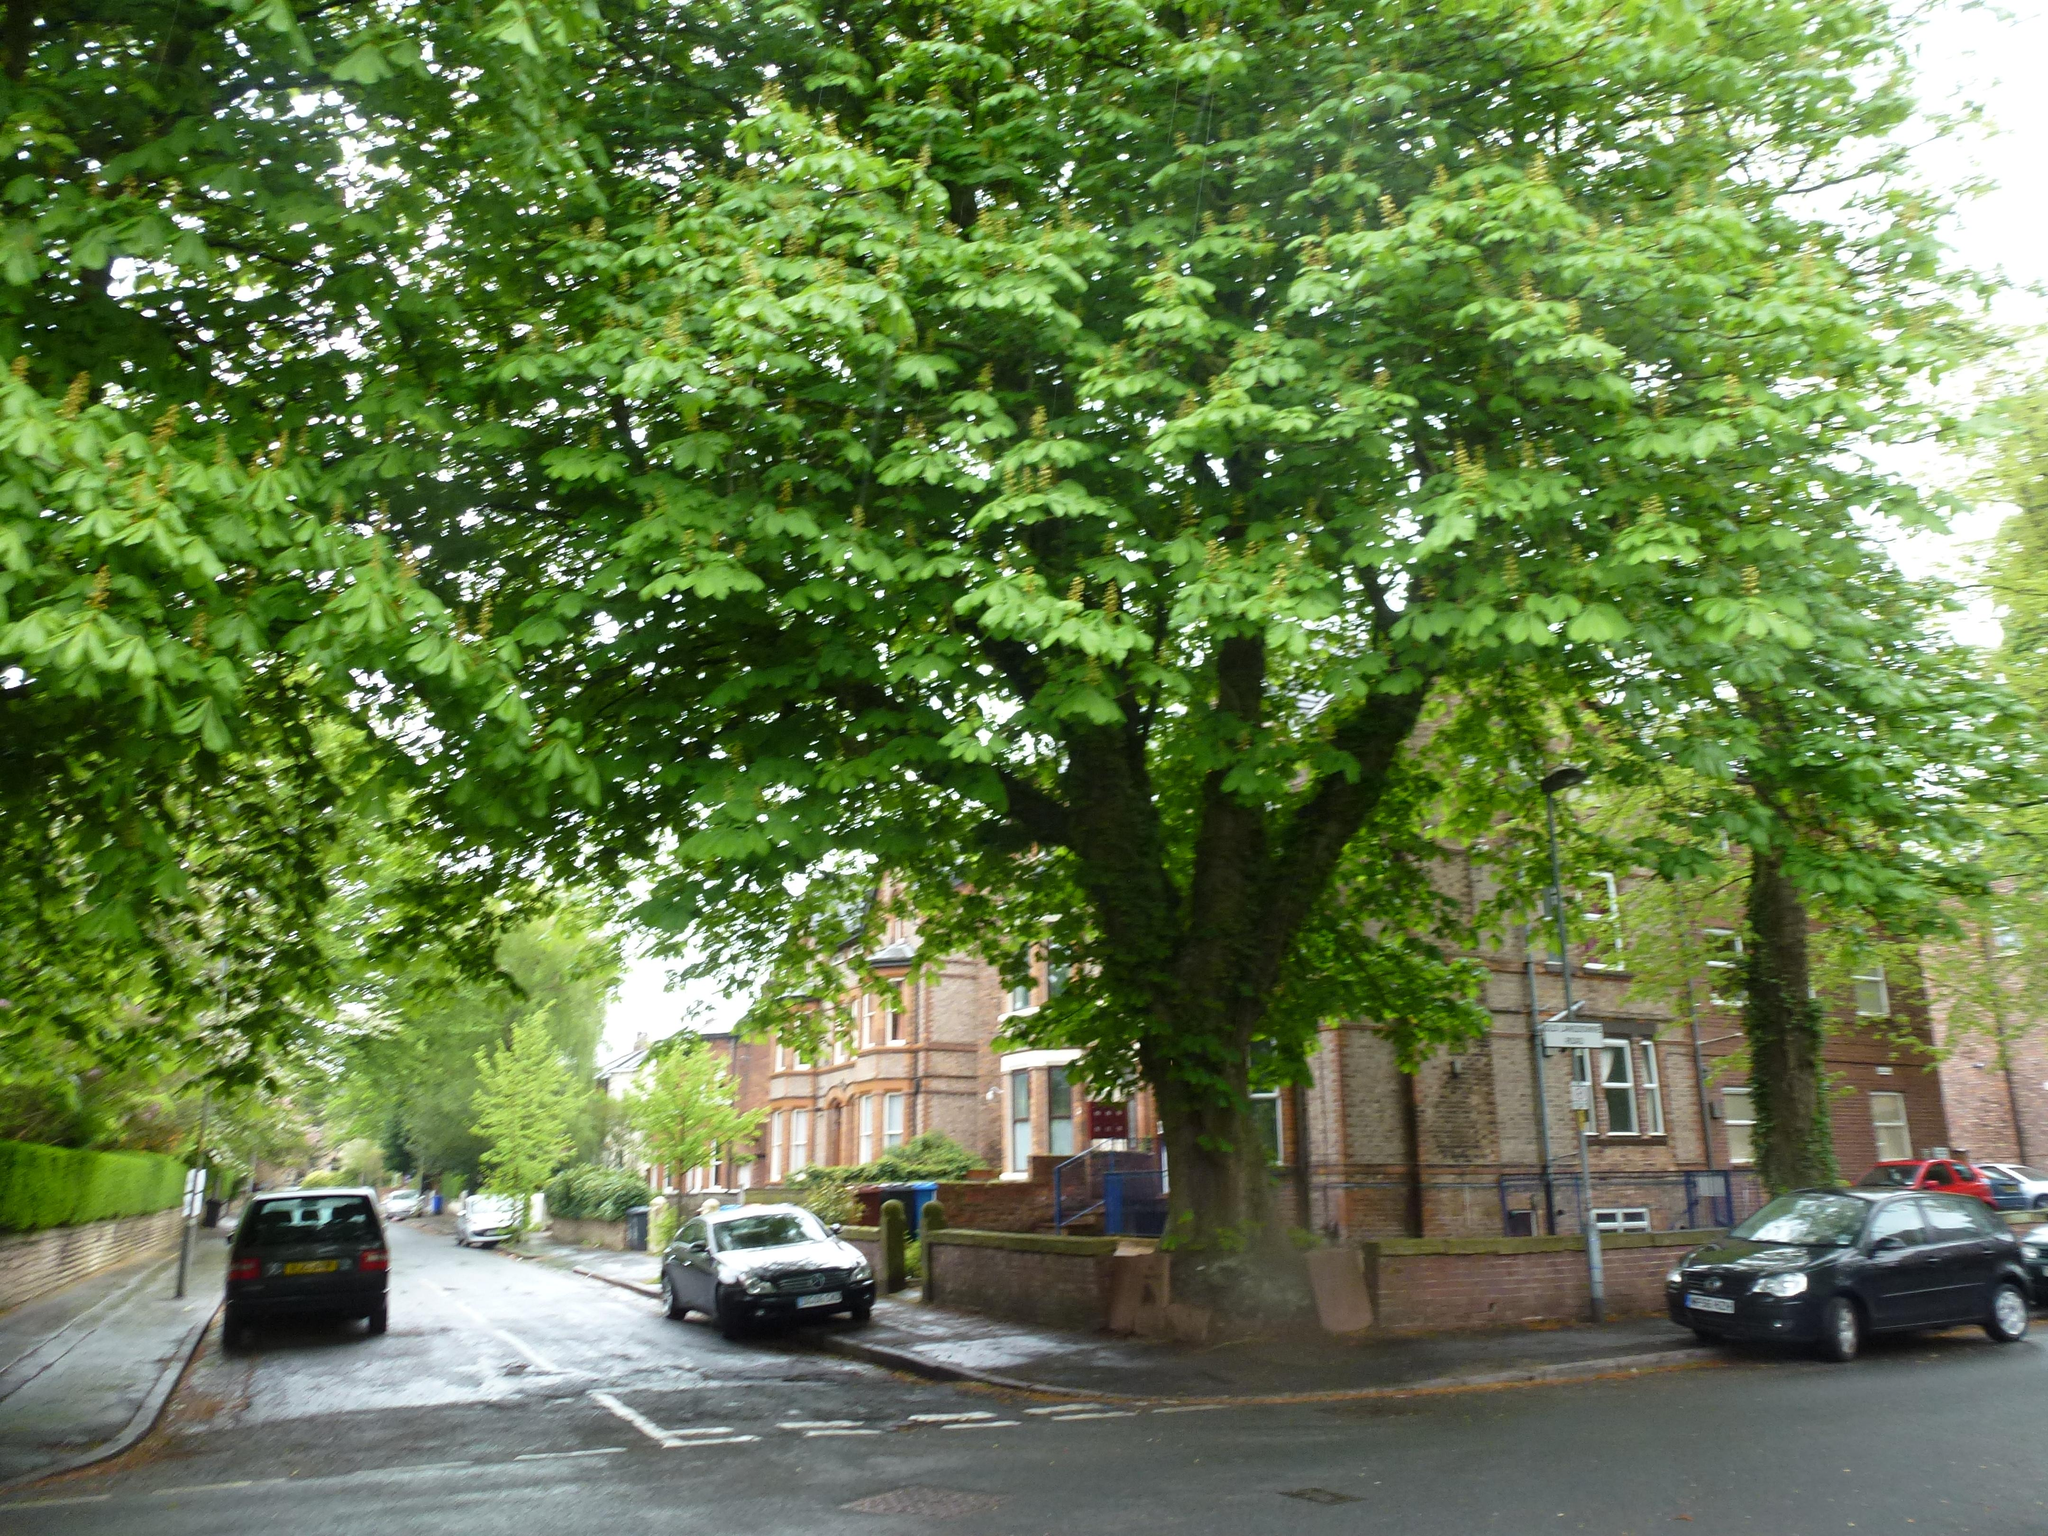What type of structures can be seen in the image? There are buildings in the image. What type of vegetation is present in the image? There are bushes and trees in the image. What type of transportation is visible on the road in the image? There are motor vehicles on the road in the image. What type of signage is present in the image? There are sign boards in the image. What type of pole is present in the image? There is a street pole in the image. What type of lighting is present in the image? There is a street light in the image. What part of the natural environment is visible in the image? The sky is visible in the image. Can you tell me how many pictures are hanging on the street pole in the image? There are no pictures hanging on the street pole in the image. Is there a man standing next to the street light in the image? There is no man present in the image. 